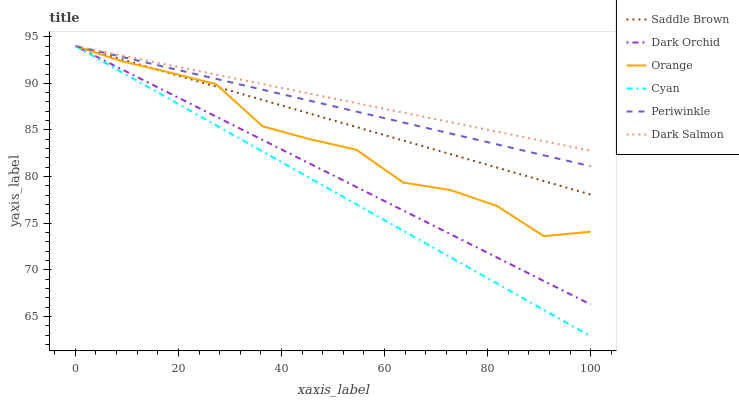Does Cyan have the minimum area under the curve?
Answer yes or no. Yes. Does Dark Salmon have the maximum area under the curve?
Answer yes or no. Yes. Does Dark Orchid have the minimum area under the curve?
Answer yes or no. No. Does Dark Orchid have the maximum area under the curve?
Answer yes or no. No. Is Periwinkle the smoothest?
Answer yes or no. Yes. Is Orange the roughest?
Answer yes or no. Yes. Is Dark Orchid the smoothest?
Answer yes or no. No. Is Dark Orchid the roughest?
Answer yes or no. No. Does Dark Orchid have the lowest value?
Answer yes or no. No. Does Saddle Brown have the highest value?
Answer yes or no. Yes. Does Orange intersect Dark Salmon?
Answer yes or no. Yes. Is Orange less than Dark Salmon?
Answer yes or no. No. Is Orange greater than Dark Salmon?
Answer yes or no. No. 